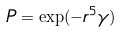<formula> <loc_0><loc_0><loc_500><loc_500>P = \exp ( - r ^ { 5 } \gamma )</formula> 